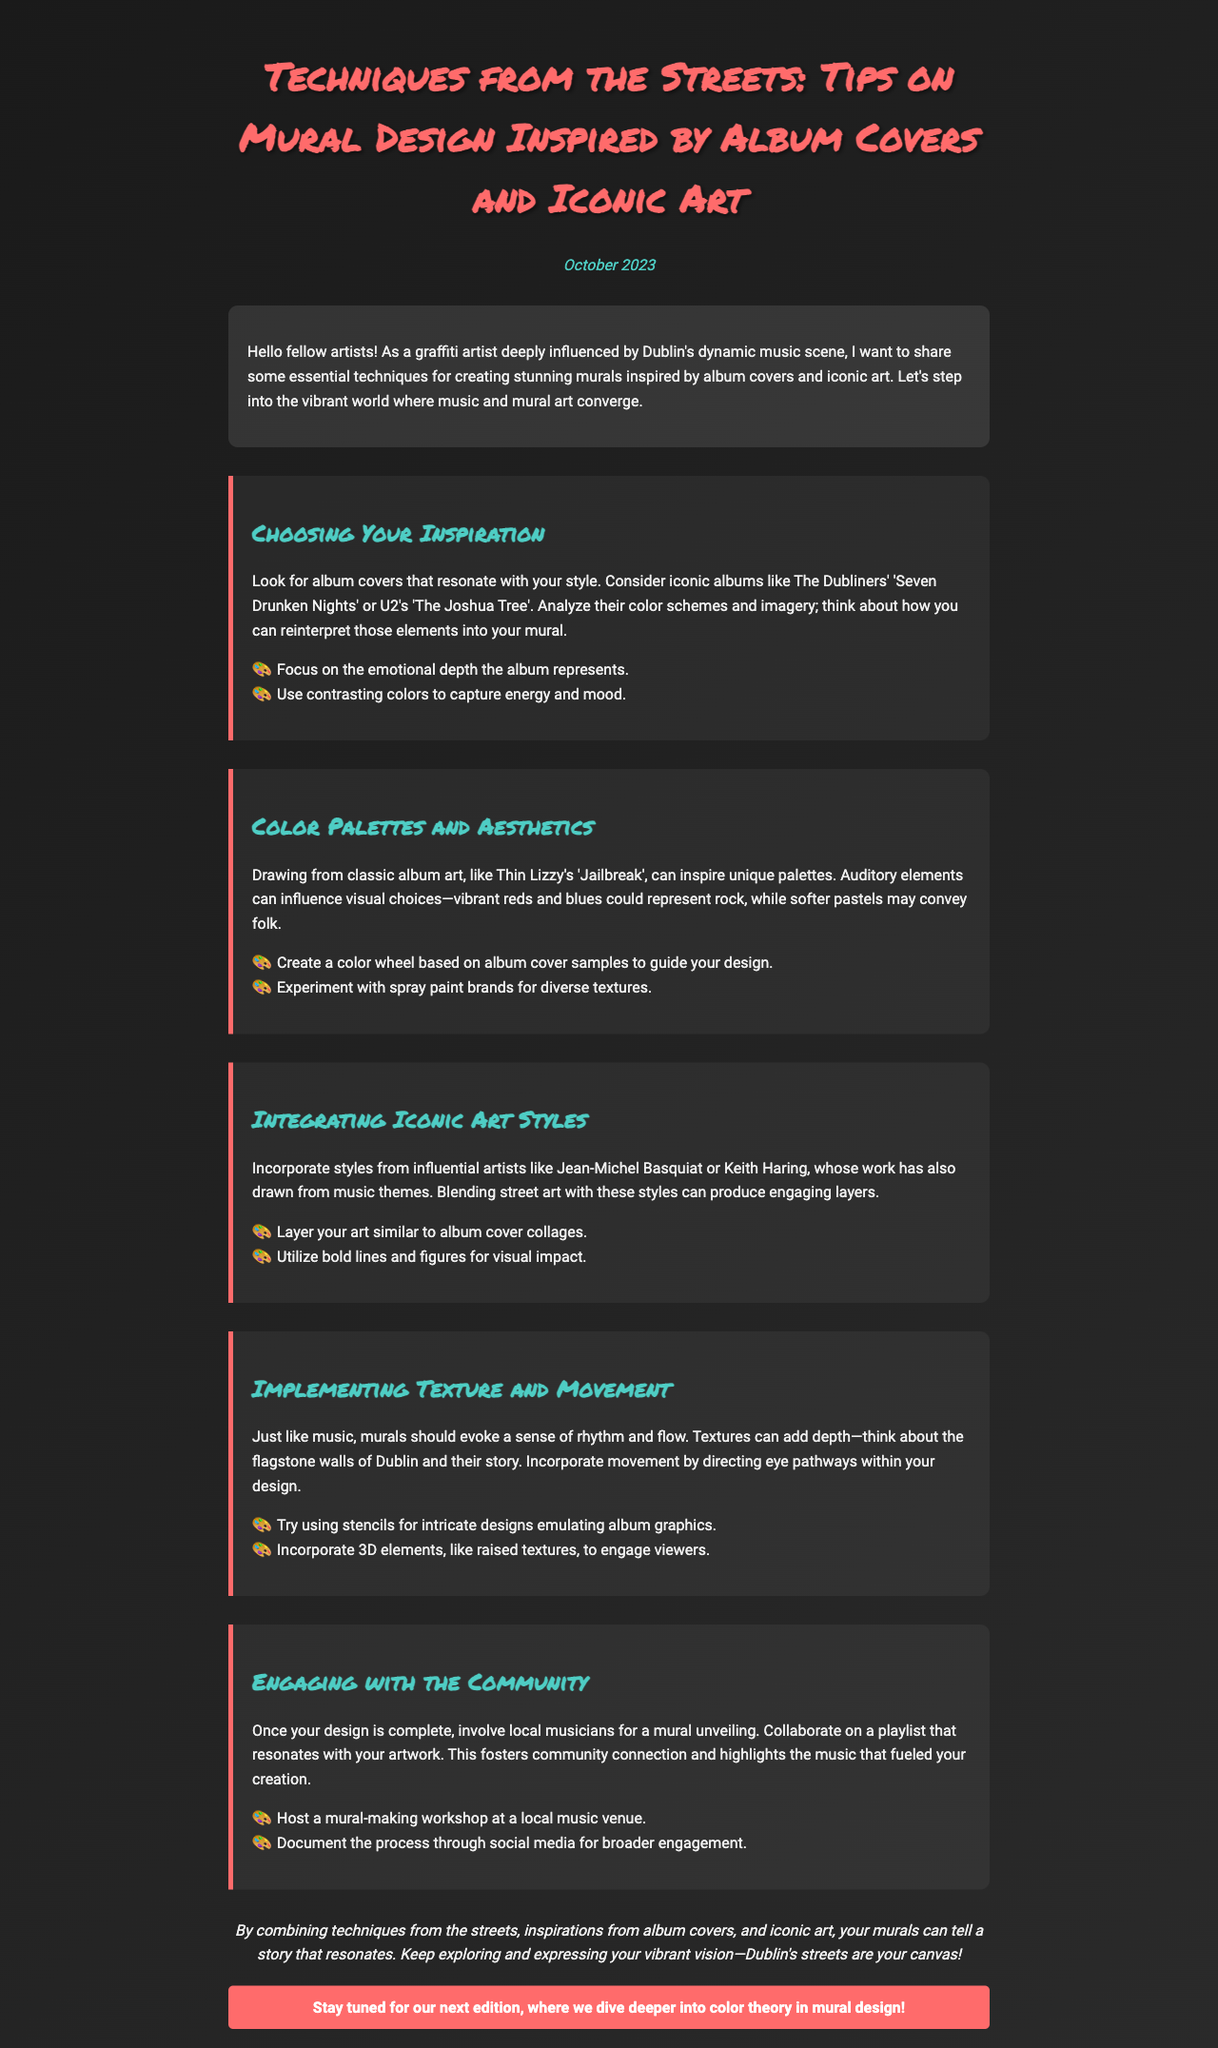What is the title of the newsletter? The title of the newsletter is prominently displayed at the top of the document.
Answer: Techniques from the Streets: Tips on Mural Design Inspired by Album Covers and Iconic Art Who is the intended audience of the newsletter? The introduction addresses the audience that the newsletter is intended for.
Answer: fellow artists What album covers are suggested for inspiration? The newsletter provides examples of specific albums for inspiration in mural design.
Answer: The Dubliners' 'Seven Drunken Nights' or U2's 'The Joshua Tree' What color palette is referenced for rock music? The newsletter mentions specific color associations related to musical genres.
Answer: vibrant reds and blues Which iconic artist's style is recommended for integration? The document references influential artists that can inspire mural styles.
Answer: Jean-Michel Basquiat How can a mural evoke movement according to the document? The section on texture and movement discusses how to create flow in a mural.
Answer: directing eye pathways What type of community engagement is suggested post-mural completion? The document advises engaging with the community through specific activities after finishing the mural.
Answer: collaborate on a playlist In which city is the mural scene particularly vibrant? The introduction mentions a specific city known for its culture and art scene.
Answer: Dublin 